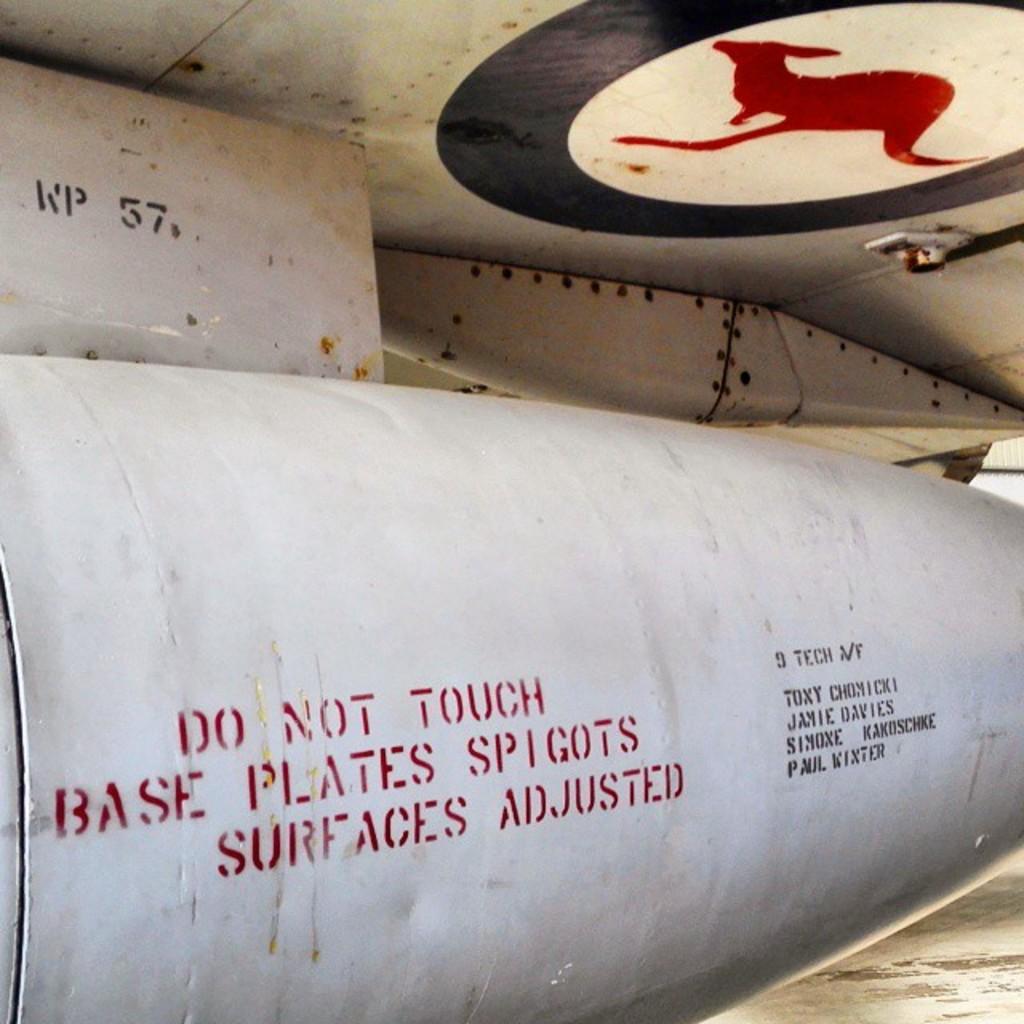What are the numbers and letters at the top?
Your answer should be very brief. Wp 57. Do not do what?
Offer a very short reply. Touch. 